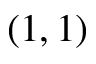<formula> <loc_0><loc_0><loc_500><loc_500>( 1 , 1 )</formula> 